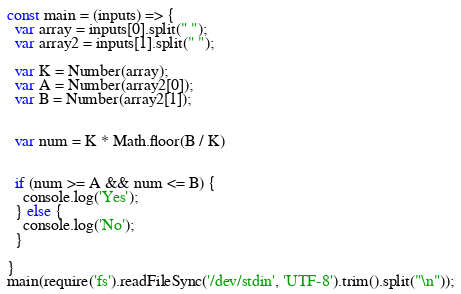<code> <loc_0><loc_0><loc_500><loc_500><_JavaScript_>const main = (inputs) => {
  var array = inputs[0].split(" ");
  var array2 = inputs[1].split(" ");

  var K = Number(array);
  var A = Number(array2[0]);
  var B = Number(array2[1]);


  var num = K * Math.floor(B / K)


  if (num >= A && num <= B) {
    console.log('Yes');
  } else {
    console.log('No');
  }

}
main(require('fs').readFileSync('/dev/stdin', 'UTF-8').trim().split("\n"));</code> 